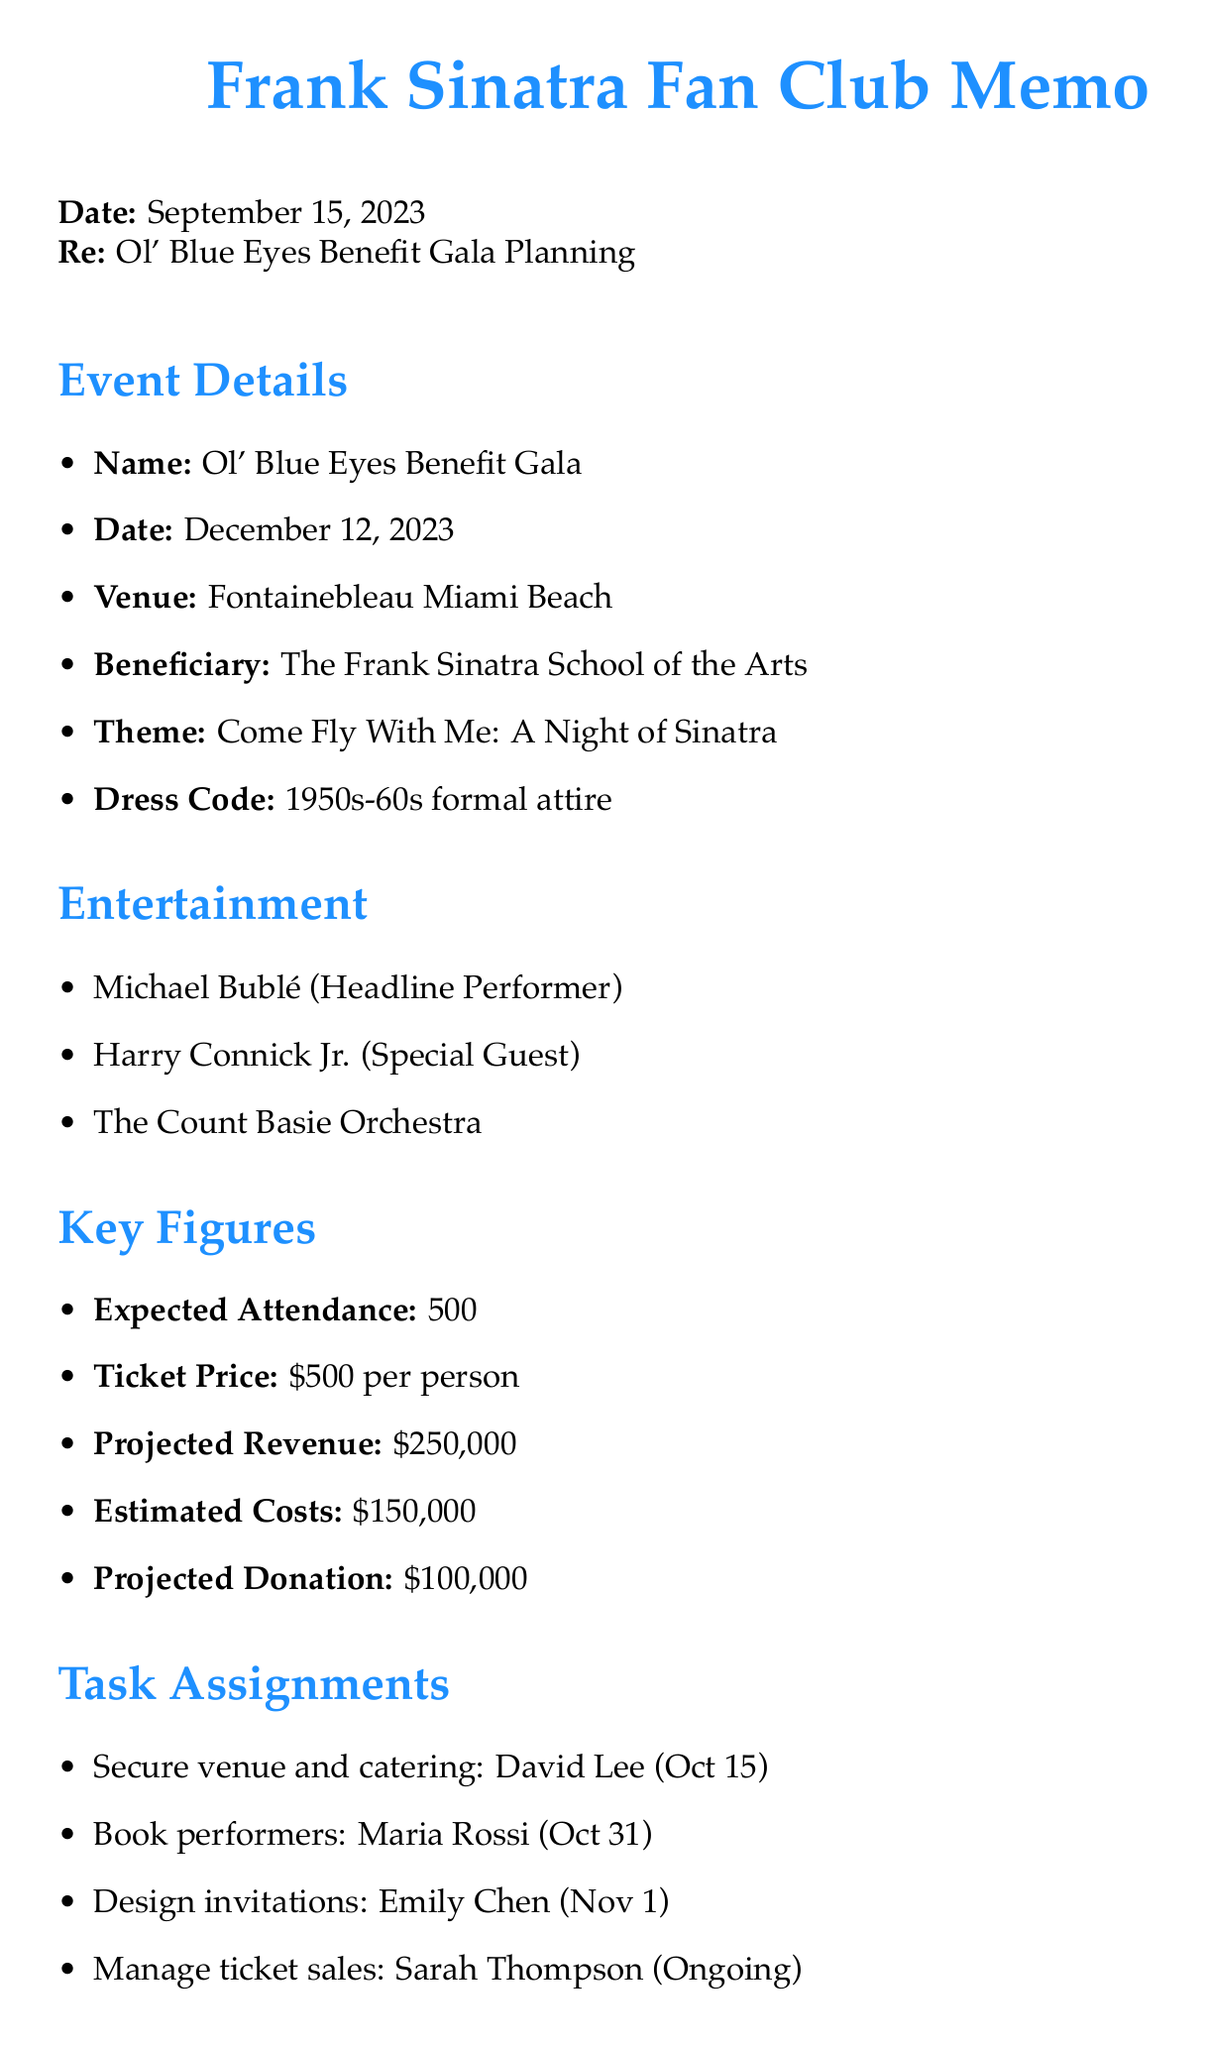What is the date of the charity event? The date of the charity event is explicitly mentioned in the document.
Answer: December 12, 2023 Who is the headline performer for the event? The document lists the performers, highlighting the headline act.
Answer: Michael Bublé What is the expected attendance number? The document specifies the number of expected attendees for the event.
Answer: 500 What is the ticket price per person? The document provides the cost for a ticket in a clear format.
Answer: $500 per person What is the primary theme of the event? The theme for the charity event is discussed in the document.
Answer: Come Fly With Me: A Night of Sinatra Who is responsible for designing and printing invitations? The task assignments section specifies who handles invitations.
Answer: Emily Chen What is the venue for the charity event? The document states the venue for the charity event directly.
Answer: Fontainebleau Miami Beach What is the projected donation amount? The expected donation amount is outlined as part of the logistics and budget section.
Answer: $100,000 When is the next meeting scheduled? The document provides the date and time for the next meeting.
Answer: October 1, 2023 